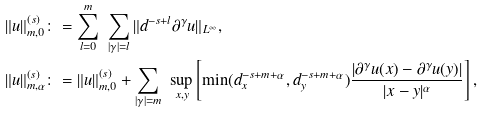Convert formula to latex. <formula><loc_0><loc_0><loc_500><loc_500>\| u \| ^ { ( s ) } _ { m , 0 } & \colon = \sum _ { l = 0 } ^ { m } \ \sum _ { | \gamma | = l } \| d ^ { - s + l } \partial ^ { \gamma } u \| _ { L ^ { \infty } } , \\ \| u \| ^ { ( s ) } _ { m , \alpha } & \colon = \| u \| ^ { ( s ) } _ { m , 0 } + \sum _ { | \gamma | = m } \ \sup _ { x , y } \left [ \min ( d _ { x } ^ { - s + m + \alpha } , d _ { y } ^ { - s + m + \alpha } ) \frac { | \partial ^ { \gamma } u ( x ) - \partial ^ { \gamma } u ( y ) | } { | x - y | ^ { \alpha } } \right ] ,</formula> 